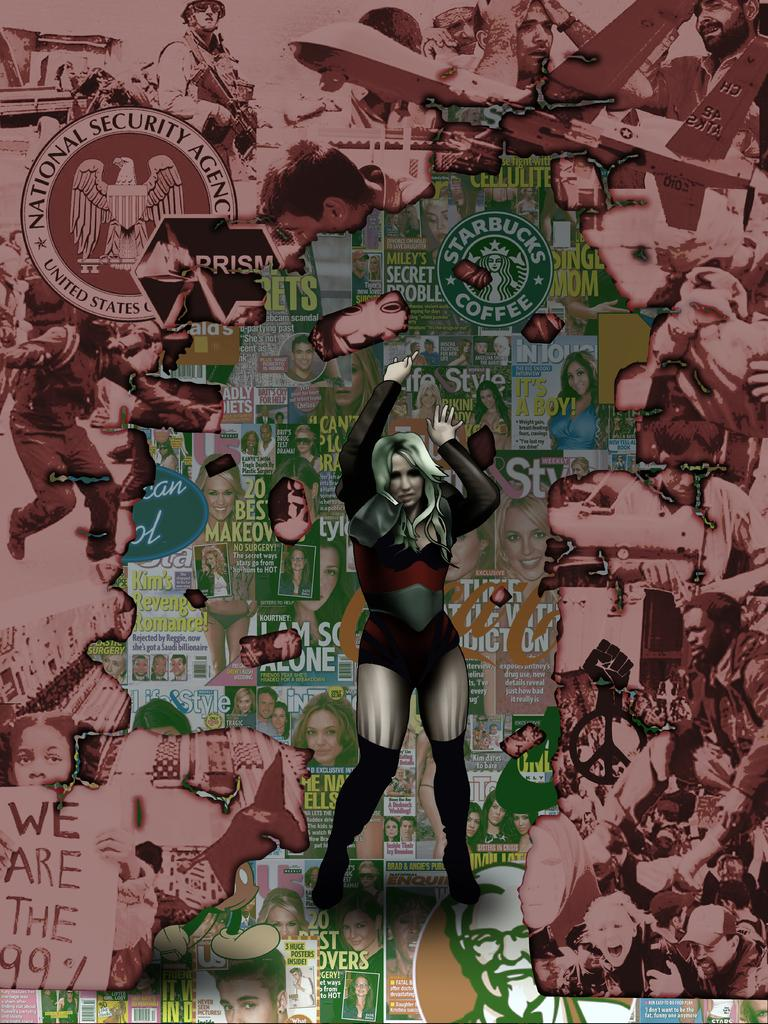<image>
Create a compact narrative representing the image presented. a magazine that has the word sty on it 